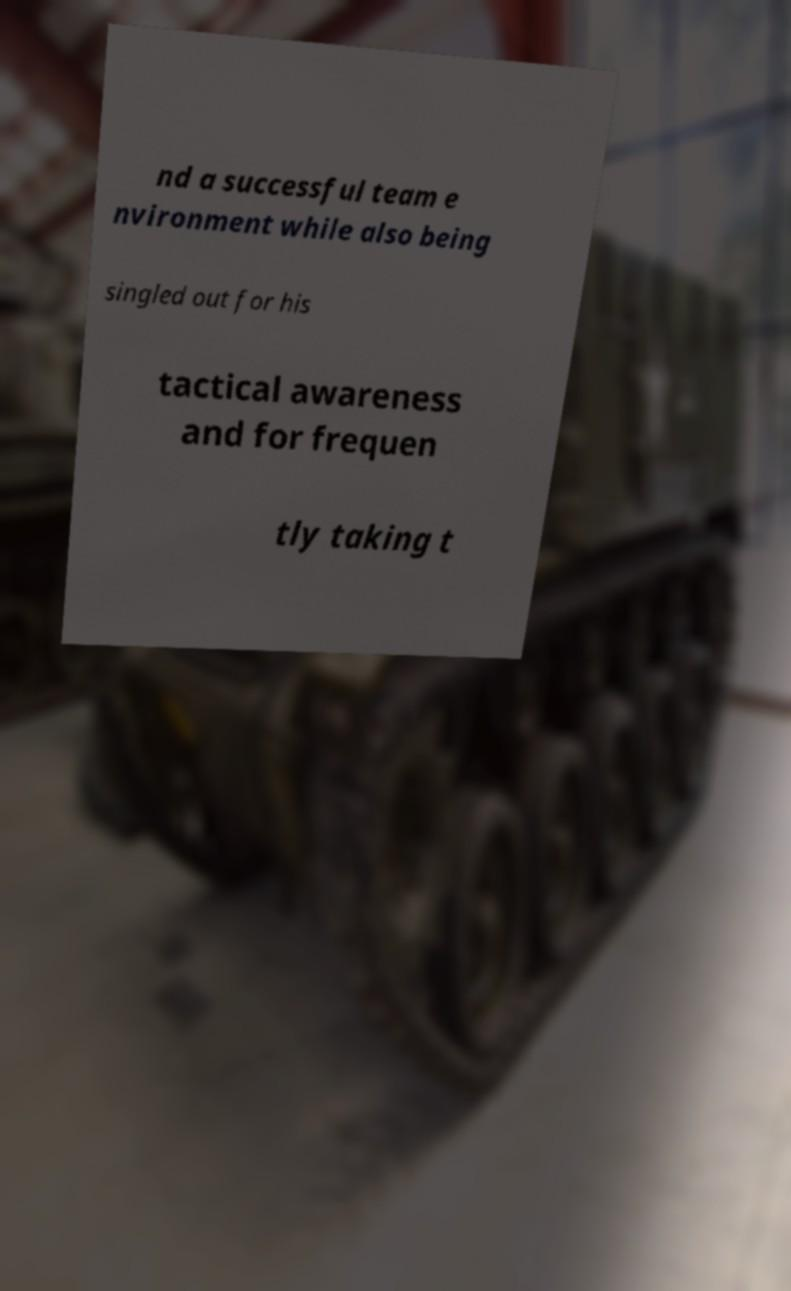Can you accurately transcribe the text from the provided image for me? nd a successful team e nvironment while also being singled out for his tactical awareness and for frequen tly taking t 